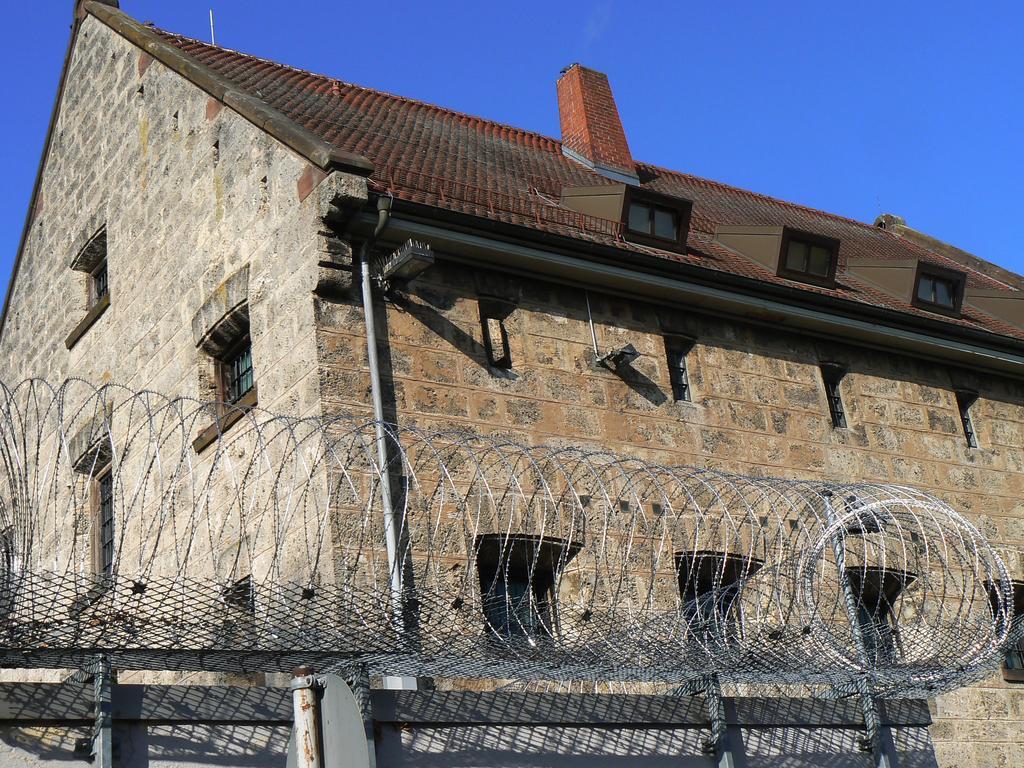Could you give a brief overview of what you see in this image? In the center of the image there is a building. At the bottom there is a fence. In the background there is sky. 